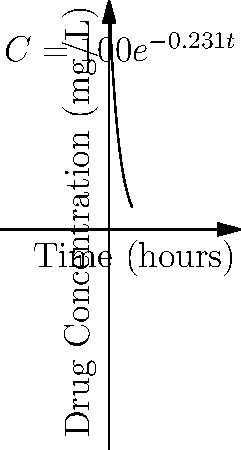As a legal podcast host discussing medical malpractice cases, you're presented with a case involving improper drug dosing. The graph shows the exponential decay of a drug's concentration in a patient's bloodstream over time. The concentration $C$ (in mg/L) at time $t$ (in hours) is given by the equation $C = 100e^{-0.231t}$. If the therapeutic range for this drug is 40-60 mg/L, after how many hours will the drug concentration first fall below the therapeutic range? To solve this problem, we need to follow these steps:

1) The lower limit of the therapeutic range is 40 mg/L. We need to find when the concentration falls below this level.

2) We can set up the equation:
   $40 = 100e^{-0.231t}$

3) Divide both sides by 100:
   $0.4 = e^{-0.231t}$

4) Take the natural log of both sides:
   $\ln(0.4) = -0.231t$

5) Solve for $t$:
   $t = \frac{\ln(0.4)}{-0.231}$

6) Calculate the result:
   $t = \frac{-0.916}{-0.231} \approx 3.97$ hours

7) Since we're asked when it first falls below the range, we round up to the next hour.

Therefore, after 4 hours, the drug concentration will first fall below the therapeutic range.
Answer: 4 hours 